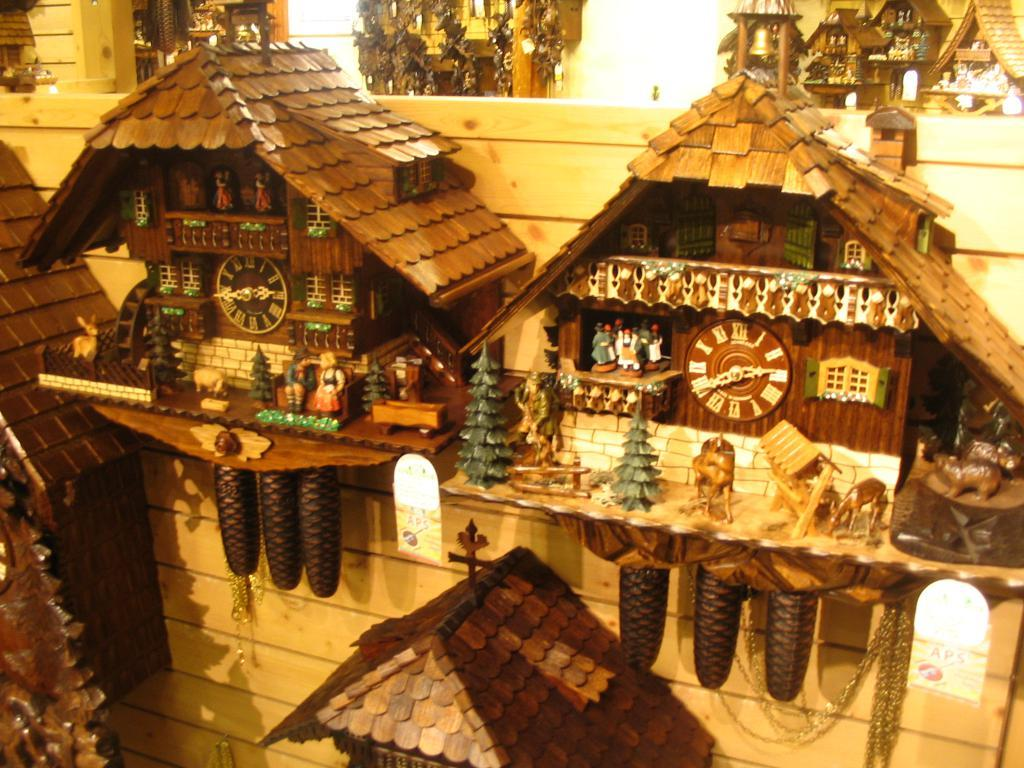What is the main subject in the foreground of the image? There are rooster clocks in the foreground of the image. How are the rooster clocks attached to the wall? The rooster clocks are attached to a wooden wall. What can be seen in the background of the image? There are many rooster clocks in the background of the image. What type of yam is being used as a decoration in the image? There is no yam present in the image; it features rooster clocks on a wooden wall. 